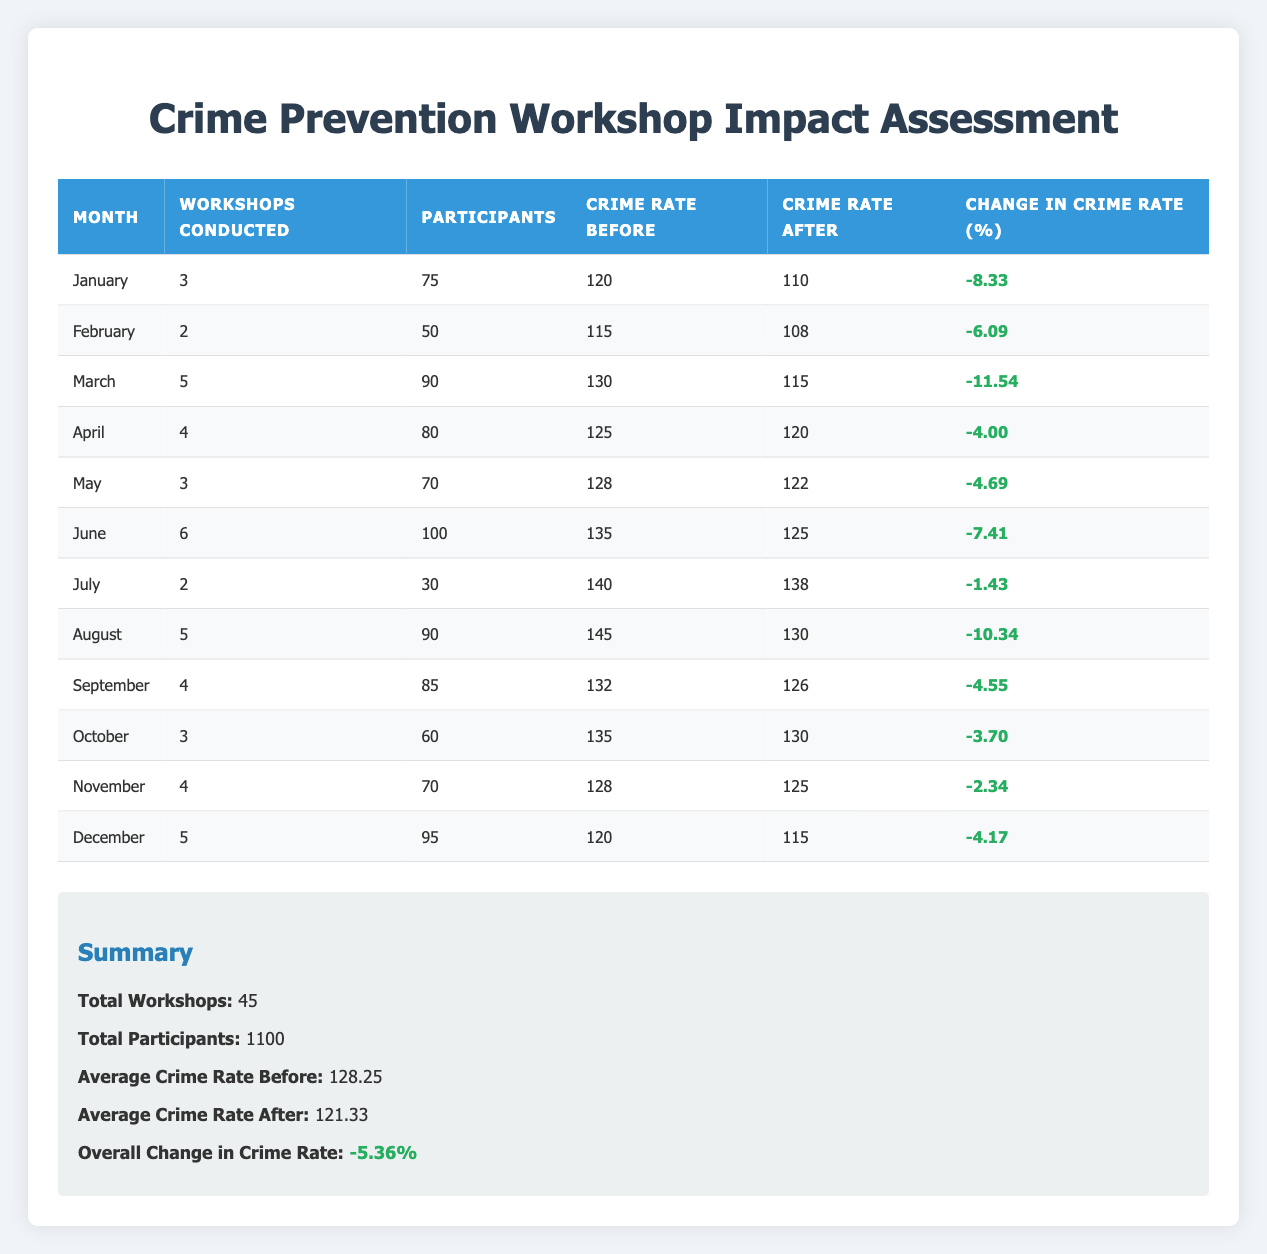What was the total number of participants in all workshops? By summing the number of participants for each month: (75 + 50 + 90 + 80 + 70 + 100 + 30 + 90 + 85 + 60 + 70 + 95) = 1100.
Answer: 1100 Which month had the highest change in the crime rate? Looking at the change in crime rate for each month, March had the highest change at -11.54%.
Answer: March Was there an increase in crime rates in any month? Reviewing the change in crime rate column, all values are negative, which means there were no increases; only decreases were observed.
Answer: No What is the average crime rate before the seminars took place? To find the average crime rate before, add all the 'Crime Rate Before' values: (120 + 115 + 130 + 125 + 128 + 135 + 140 + 145 + 132 + 135 + 128 + 120) = 1535. Divide by the number of months (12): 1535 / 12 = 128.25.
Answer: 128.25 Did the number of workshops conducted in June exceed the average of workshops conducted throughout the year? The total number of workshops is 45 over 12 months, averaging 3.75 workshops per month. June had 6 workshops, which is higher.
Answer: Yes What percentage reduction in crime rate was seen in August? In August, the crime rate decreased from 145 to 130. The change is calculated as ((145 - 130) / 145) * 100 = 10.34%.
Answer: 10.34% Calculate the total change in crime rate over the 12 months. To find the total change, sum all change values: (-8.33 - 6.09 - 11.54 - 4.00 - 4.69 - 7.41 - 1.43 - 10.34 - 4.55 - 3.70 - 2.34 - 4.17) = -5.36% per month. This shows a slight decrease when divided over the workshops.
Answer: -5.36% In which month did the smallest change in crime rate occur? Analyzing the change in crime rate for each month, July had the smallest change at -1.43%.
Answer: July Was the average crime rate after the workshops lower than before? Comparing the average crime rates, before was 128.25 and after was 121.33, showing a decrease.
Answer: Yes 